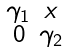<formula> <loc_0><loc_0><loc_500><loc_500>\begin{smallmatrix} \gamma _ { 1 } & x \\ 0 & \gamma _ { 2 } \end{smallmatrix}</formula> 